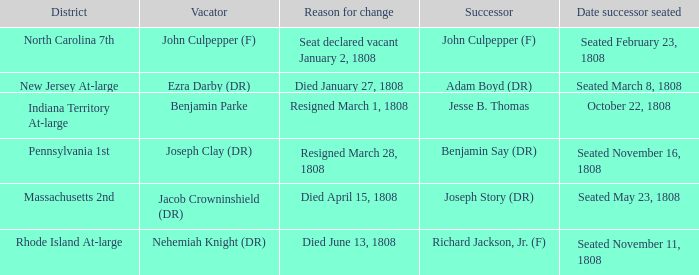Which district has John Culpepper (f) as the vacator? North Carolina 7th. 